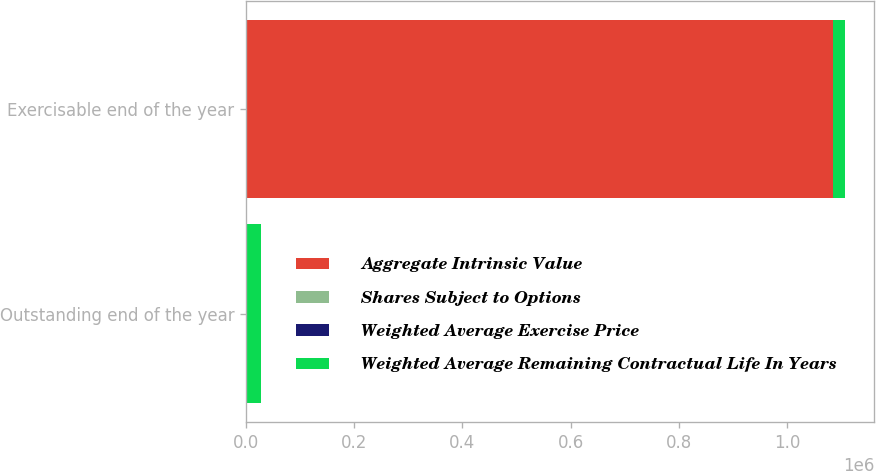Convert chart to OTSL. <chart><loc_0><loc_0><loc_500><loc_500><stacked_bar_chart><ecel><fcel>Outstanding end of the year<fcel>Exercisable end of the year<nl><fcel>Aggregate Intrinsic Value<fcel>51.96<fcel>1.08492e+06<nl><fcel>Shares Subject to Options<fcel>51.96<fcel>45.17<nl><fcel>Weighted Average Exercise Price<fcel>7.2<fcel>5.7<nl><fcel>Weighted Average Remaining Contractual Life In Years<fcel>26981<fcel>21070<nl></chart> 